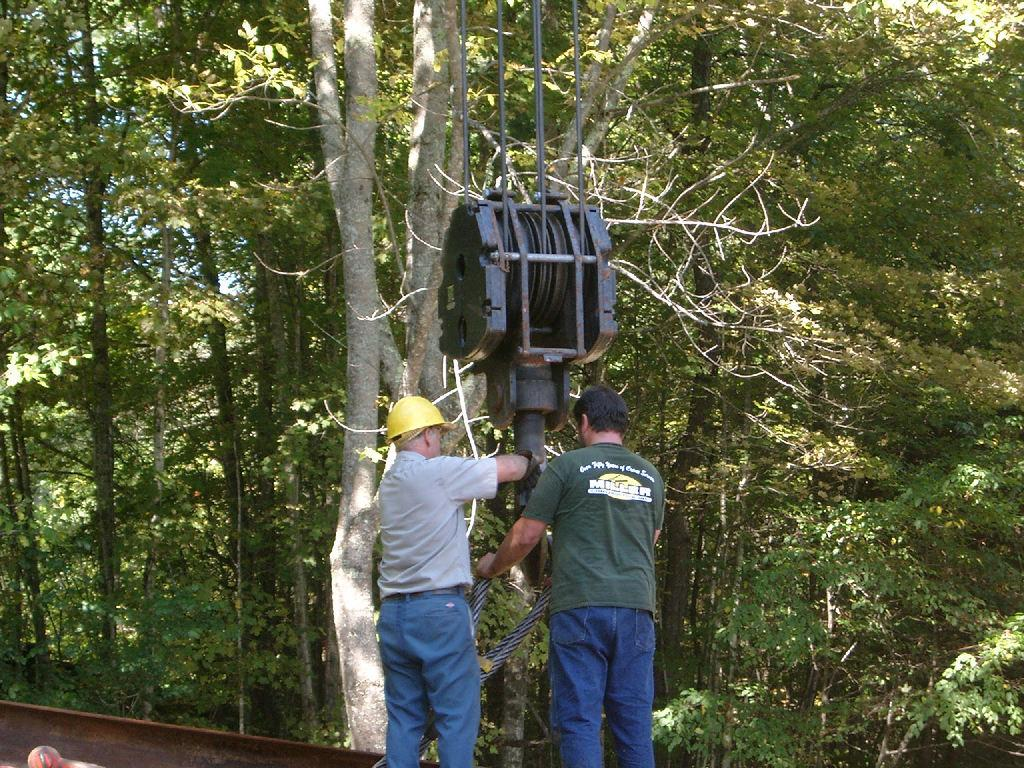How many men are in the image? There are two men in the image. What is one of the men wearing? One of the men is wearing a helmet. What device is present in the image? A: There is a pulley in the image. What is used to connect the pulley to the men? There is a rope in the image. What can be seen between the men and the pulley? There are objects in front of the men. What can be seen in the distance in the image? There are trees visible in the background of the image. What religious symbol can be seen in the image? There is no religious symbol present in the image. What idea does the image represent? The image does not represent any specific idea; it is a scene with two men, a pulley, and a rope. 